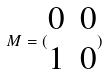<formula> <loc_0><loc_0><loc_500><loc_500>M = ( \begin{matrix} 0 & 0 \\ 1 & 0 \end{matrix} )</formula> 